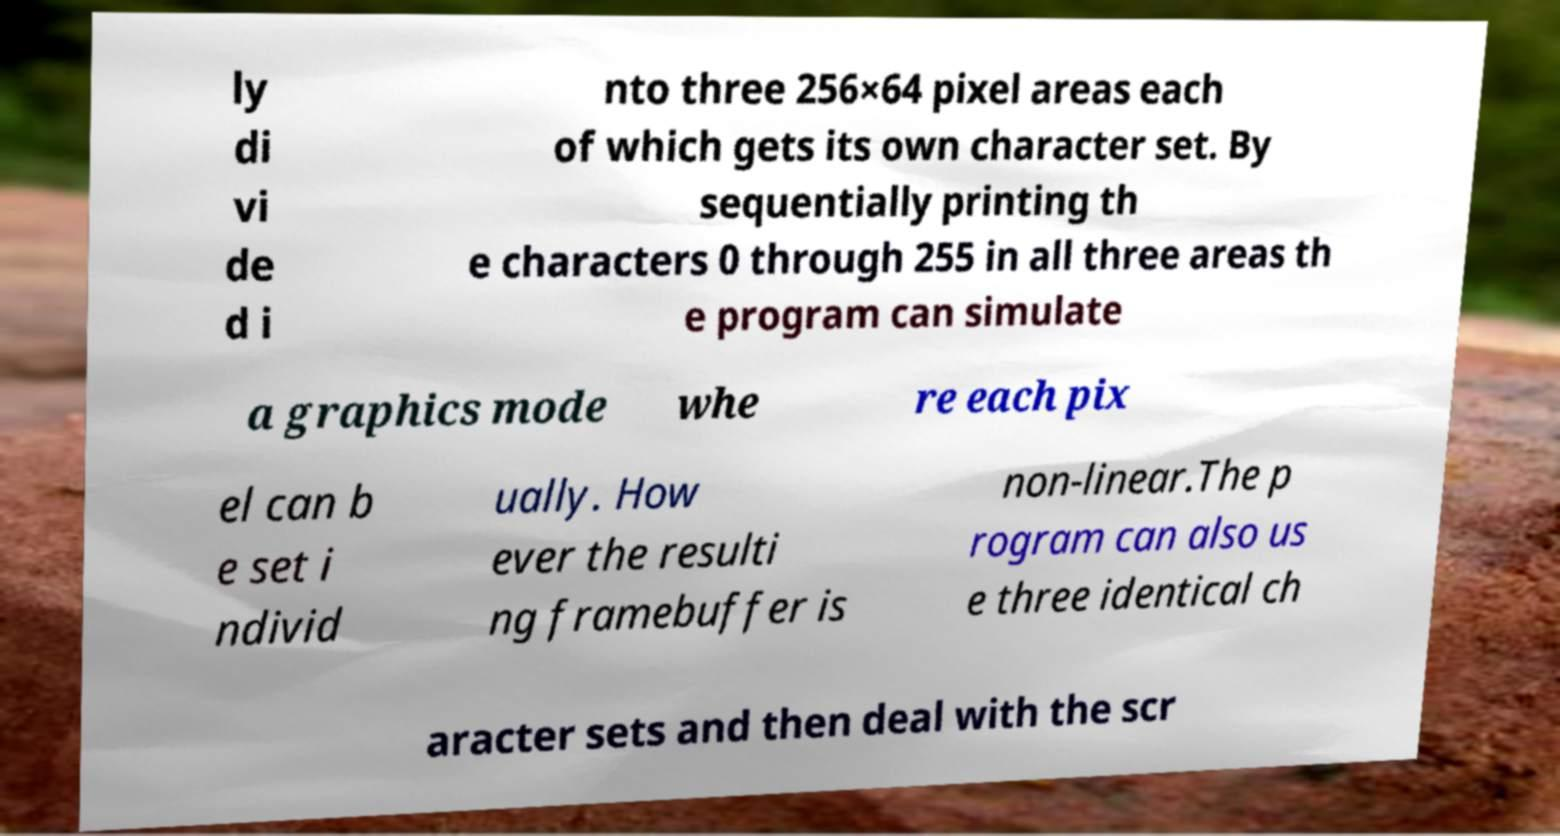I need the written content from this picture converted into text. Can you do that? ly di vi de d i nto three 256×64 pixel areas each of which gets its own character set. By sequentially printing th e characters 0 through 255 in all three areas th e program can simulate a graphics mode whe re each pix el can b e set i ndivid ually. How ever the resulti ng framebuffer is non-linear.The p rogram can also us e three identical ch aracter sets and then deal with the scr 